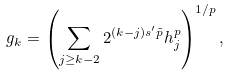Convert formula to latex. <formula><loc_0><loc_0><loc_500><loc_500>g _ { k } = \left ( \sum _ { j \geq k - 2 } 2 ^ { ( k - j ) s ^ { \prime } \tilde { p } } h _ { j } ^ { p } \right ) ^ { 1 / p } ,</formula> 